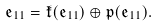Convert formula to latex. <formula><loc_0><loc_0><loc_500><loc_500>\mathfrak { e } _ { 1 1 } = \mathfrak { k } ( \mathfrak { e } _ { 1 1 } ) \oplus \mathfrak { p } ( \mathfrak { e } _ { 1 1 } ) .</formula> 